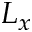<formula> <loc_0><loc_0><loc_500><loc_500>L _ { x }</formula> 